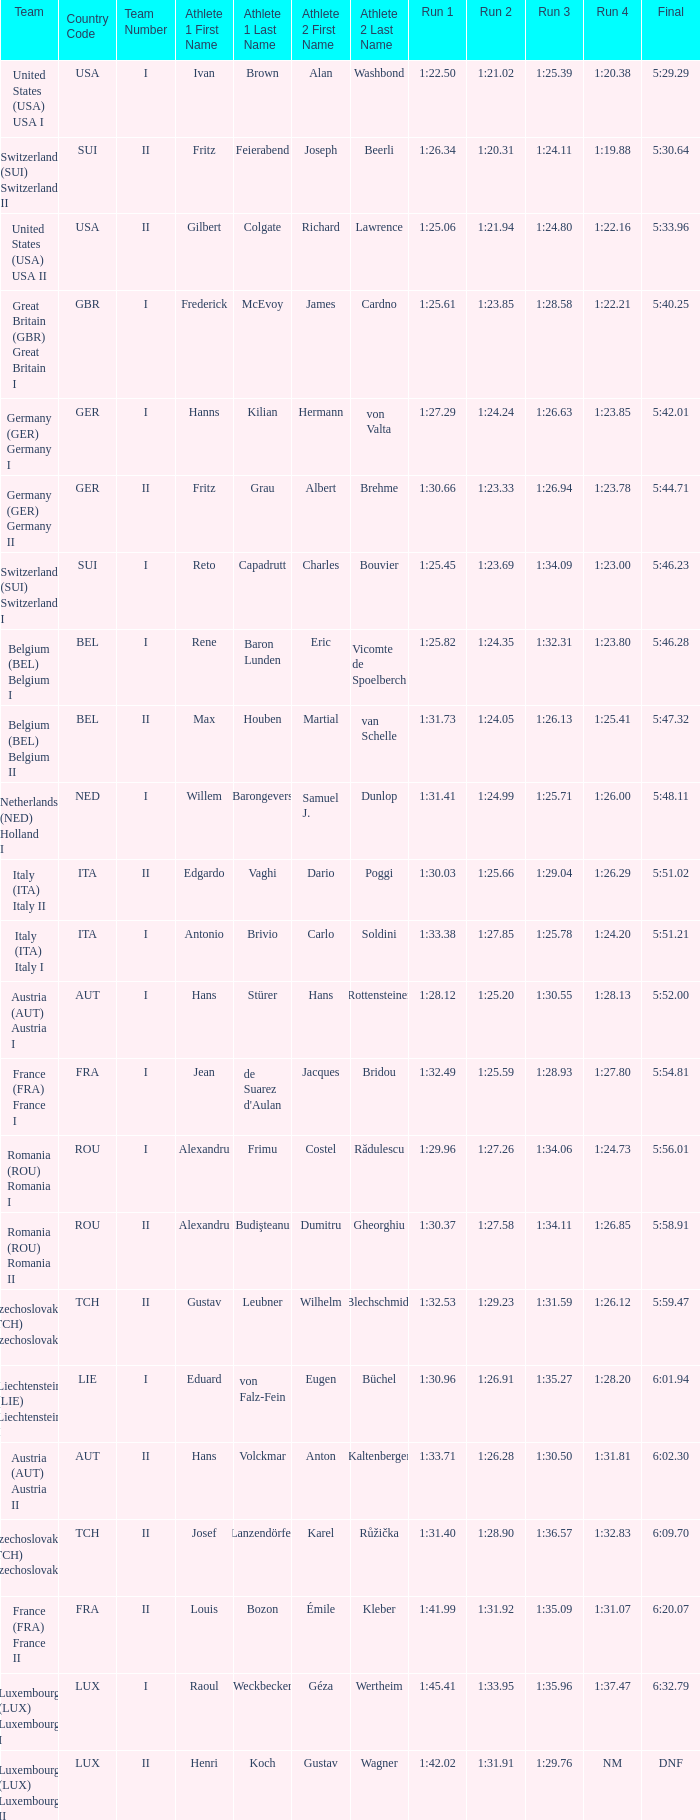In which final does the run 2 have a duration of 1 minute, 27.58 seconds? 5:58.91. 